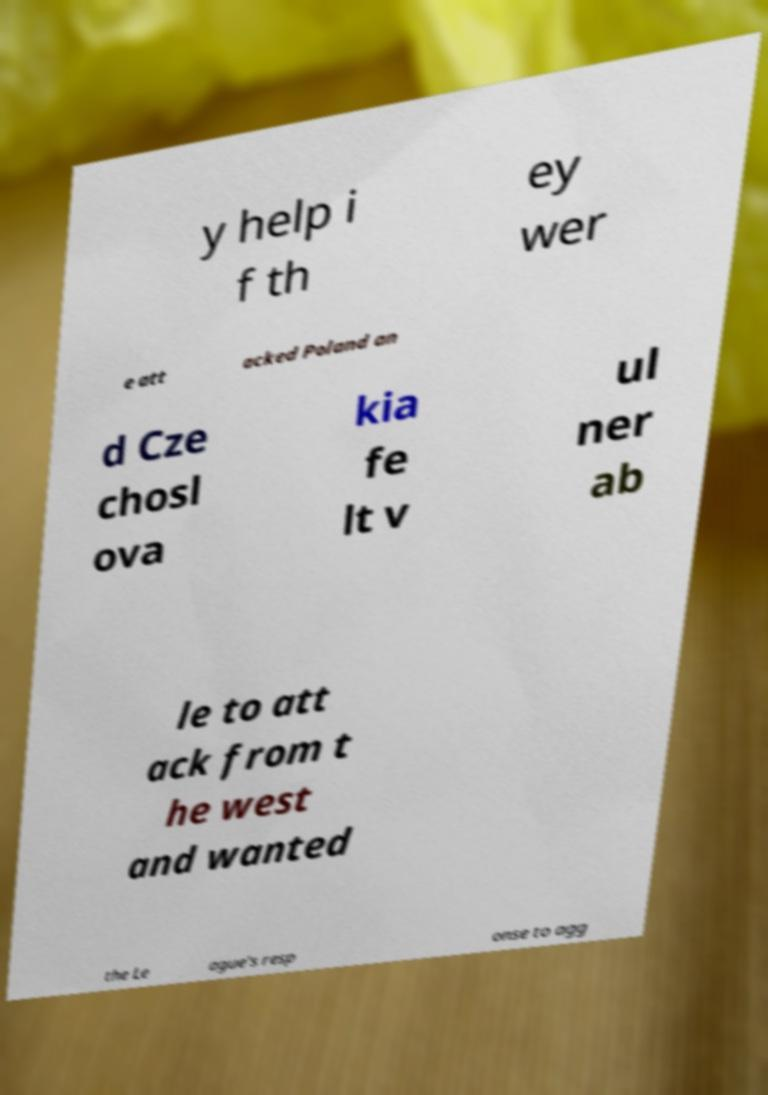Could you extract and type out the text from this image? y help i f th ey wer e att acked Poland an d Cze chosl ova kia fe lt v ul ner ab le to att ack from t he west and wanted the Le ague's resp onse to agg 